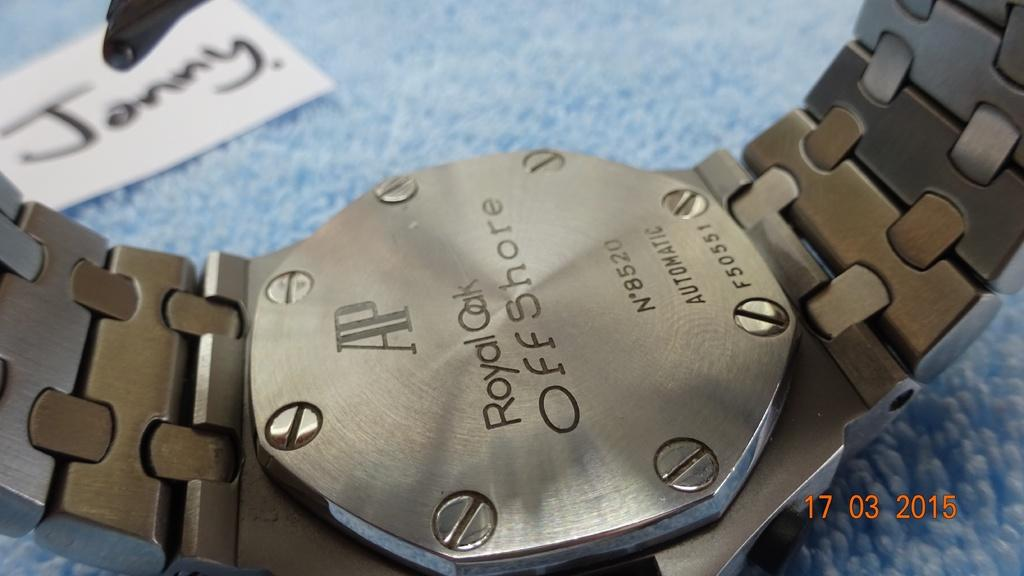<image>
Offer a succinct explanation of the picture presented. The watch has the serial code "F50551" on the back of the watch. 